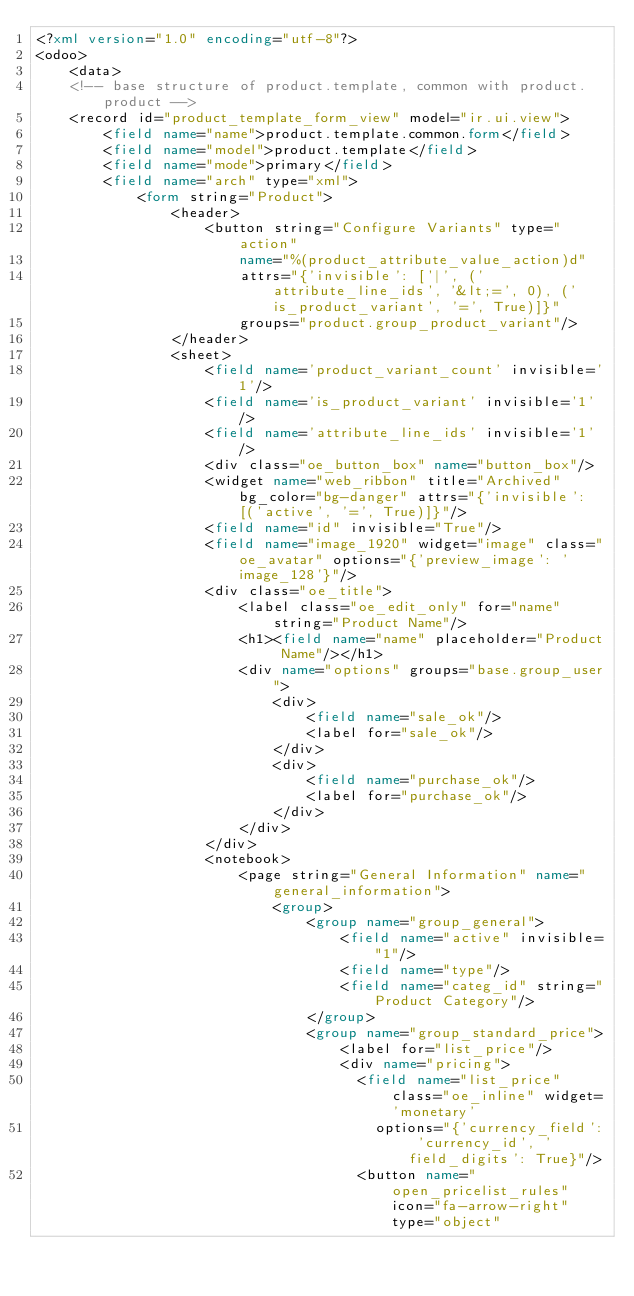<code> <loc_0><loc_0><loc_500><loc_500><_XML_><?xml version="1.0" encoding="utf-8"?>
<odoo>
    <data>
    <!-- base structure of product.template, common with product.product -->
    <record id="product_template_form_view" model="ir.ui.view">
        <field name="name">product.template.common.form</field>
        <field name="model">product.template</field>
        <field name="mode">primary</field>
        <field name="arch" type="xml">
            <form string="Product">
                <header>
                    <button string="Configure Variants" type="action"
                        name="%(product_attribute_value_action)d"
                        attrs="{'invisible': ['|', ('attribute_line_ids', '&lt;=', 0), ('is_product_variant', '=', True)]}"
                        groups="product.group_product_variant"/>
                </header>
                <sheet>
                    <field name='product_variant_count' invisible='1'/>
                    <field name='is_product_variant' invisible='1'/>
                    <field name='attribute_line_ids' invisible='1'/>
                    <div class="oe_button_box" name="button_box"/>
                    <widget name="web_ribbon" title="Archived" bg_color="bg-danger" attrs="{'invisible': [('active', '=', True)]}"/>
                    <field name="id" invisible="True"/>
                    <field name="image_1920" widget="image" class="oe_avatar" options="{'preview_image': 'image_128'}"/>
                    <div class="oe_title">
                        <label class="oe_edit_only" for="name" string="Product Name"/>
                        <h1><field name="name" placeholder="Product Name"/></h1>
                        <div name="options" groups="base.group_user">
                            <div>
                                <field name="sale_ok"/>
                                <label for="sale_ok"/>
                            </div>
                            <div>
                                <field name="purchase_ok"/>
                                <label for="purchase_ok"/>
                            </div>
                        </div>
                    </div>
                    <notebook>
                        <page string="General Information" name="general_information">
                            <group>
                                <group name="group_general">
                                    <field name="active" invisible="1"/>
                                    <field name="type"/>
                                    <field name="categ_id" string="Product Category"/>
                                </group>
                                <group name="group_standard_price">
                                    <label for="list_price"/>
                                    <div name="pricing">
                                      <field name="list_price" class="oe_inline" widget='monetary'
                                        options="{'currency_field': 'currency_id', 'field_digits': True}"/>
                                      <button name="open_pricelist_rules" icon="fa-arrow-right" type="object"</code> 